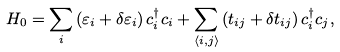Convert formula to latex. <formula><loc_0><loc_0><loc_500><loc_500>H _ { 0 } = \sum _ { i } \left ( \varepsilon _ { i } + \delta \varepsilon _ { i } \right ) c _ { i } ^ { \dagger } c _ { i } + \sum _ { \left \langle i , j \right \rangle } \left ( t _ { i j } + \delta t _ { i j } \right ) c _ { i } ^ { \dagger } c _ { j } ,</formula> 